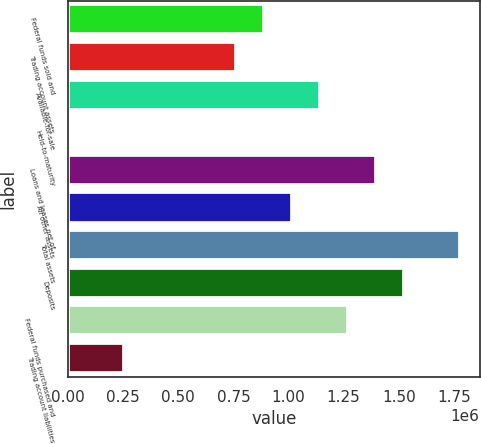Convert chart. <chart><loc_0><loc_0><loc_500><loc_500><bar_chart><fcel>Federal funds sold and<fcel>Trading account assets<fcel>Available-for-sale<fcel>Held-to-maturity<fcel>Loans and leases net of<fcel>All other assets<fcel>Total assets<fcel>Deposits<fcel>Federal funds purchased and<fcel>Trading account liabilities<nl><fcel>888982<fcel>762012<fcel>1.14292e+06<fcel>192<fcel>1.39686e+06<fcel>1.01595e+06<fcel>1.77777e+06<fcel>1.52383e+06<fcel>1.26989e+06<fcel>254132<nl></chart> 